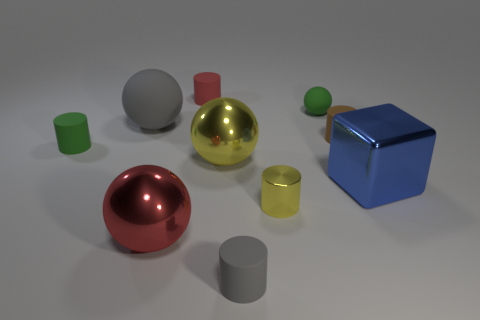What is the material of the brown cylinder?
Give a very brief answer. Rubber. There is a big red metal object; what shape is it?
Your answer should be very brief. Sphere. How many rubber things have the same color as the large block?
Keep it short and to the point. 0. What material is the tiny green object that is in front of the tiny green matte thing on the right side of the matte cylinder in front of the small green cylinder?
Keep it short and to the point. Rubber. What number of yellow objects are either big metallic things or small shiny cylinders?
Provide a short and direct response. 2. There is a rubber sphere on the right side of the gray matte object in front of the tiny green matte thing left of the small red thing; what is its size?
Offer a very short reply. Small. There is a brown rubber object that is the same shape as the tiny shiny object; what is its size?
Offer a terse response. Small. What number of small things are red rubber cylinders or brown blocks?
Your answer should be very brief. 1. Do the gray object in front of the green matte cylinder and the object behind the tiny green ball have the same material?
Give a very brief answer. Yes. There is a tiny gray cylinder in front of the big blue metallic cube; what is its material?
Give a very brief answer. Rubber. 